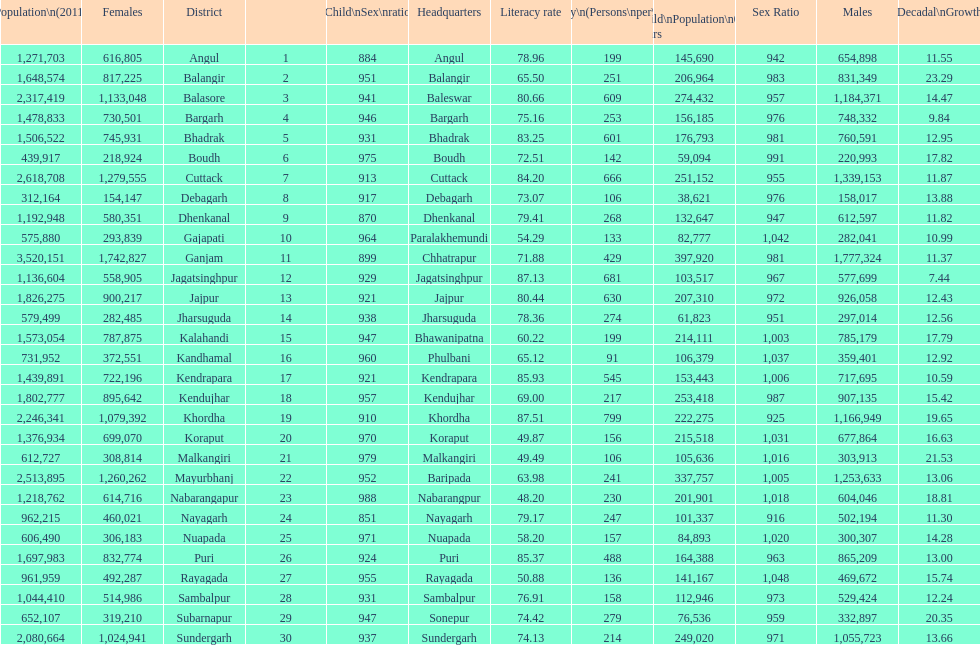What city is last in literacy? Nabarangapur. 